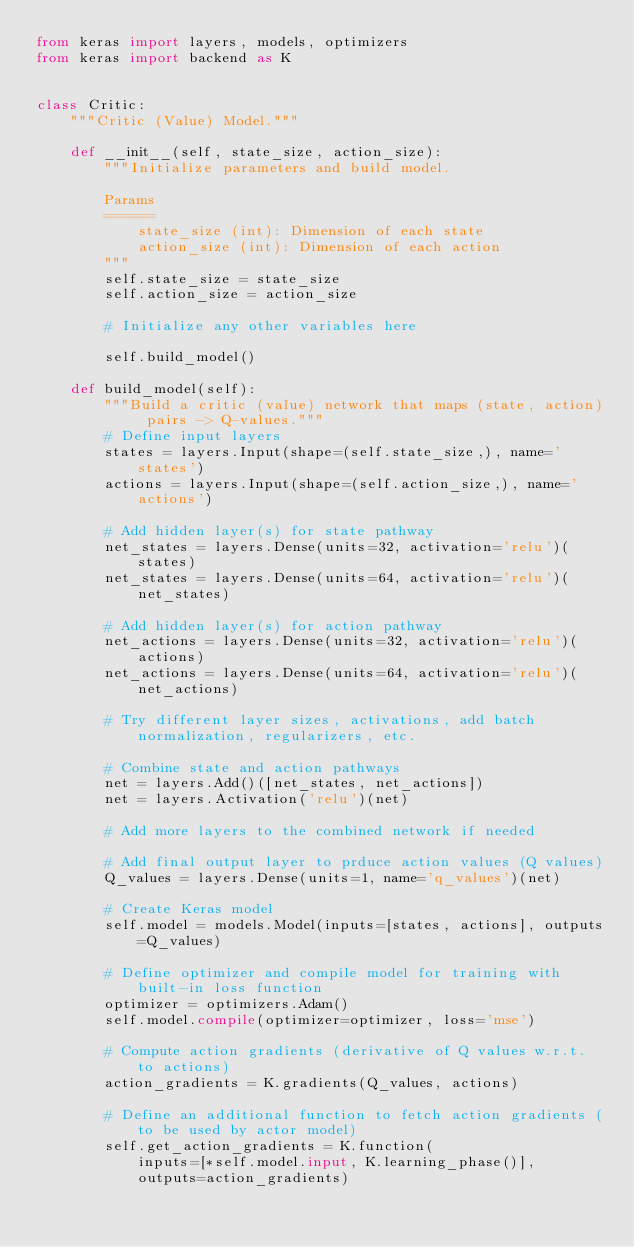<code> <loc_0><loc_0><loc_500><loc_500><_Python_>from keras import layers, models, optimizers
from keras import backend as K


class Critic:
    """Critic (Value) Model."""

    def __init__(self, state_size, action_size):
        """Initialize parameters and build model.

        Params
        ======
            state_size (int): Dimension of each state
            action_size (int): Dimension of each action
        """
        self.state_size = state_size
        self.action_size = action_size

        # Initialize any other variables here

        self.build_model()

    def build_model(self):
        """Build a critic (value) network that maps (state, action) pairs -> Q-values."""
        # Define input layers
        states = layers.Input(shape=(self.state_size,), name='states')
        actions = layers.Input(shape=(self.action_size,), name='actions')

        # Add hidden layer(s) for state pathway
        net_states = layers.Dense(units=32, activation='relu')(states)
        net_states = layers.Dense(units=64, activation='relu')(net_states)

        # Add hidden layer(s) for action pathway
        net_actions = layers.Dense(units=32, activation='relu')(actions)
        net_actions = layers.Dense(units=64, activation='relu')(net_actions)

        # Try different layer sizes, activations, add batch normalization, regularizers, etc.

        # Combine state and action pathways
        net = layers.Add()([net_states, net_actions])
        net = layers.Activation('relu')(net)

        # Add more layers to the combined network if needed

        # Add final output layer to prduce action values (Q values)
        Q_values = layers.Dense(units=1, name='q_values')(net)

        # Create Keras model
        self.model = models.Model(inputs=[states, actions], outputs=Q_values)

        # Define optimizer and compile model for training with built-in loss function
        optimizer = optimizers.Adam()
        self.model.compile(optimizer=optimizer, loss='mse')

        # Compute action gradients (derivative of Q values w.r.t. to actions)
        action_gradients = K.gradients(Q_values, actions)

        # Define an additional function to fetch action gradients (to be used by actor model)
        self.get_action_gradients = K.function(
            inputs=[*self.model.input, K.learning_phase()],
            outputs=action_gradients)
        
        </code> 